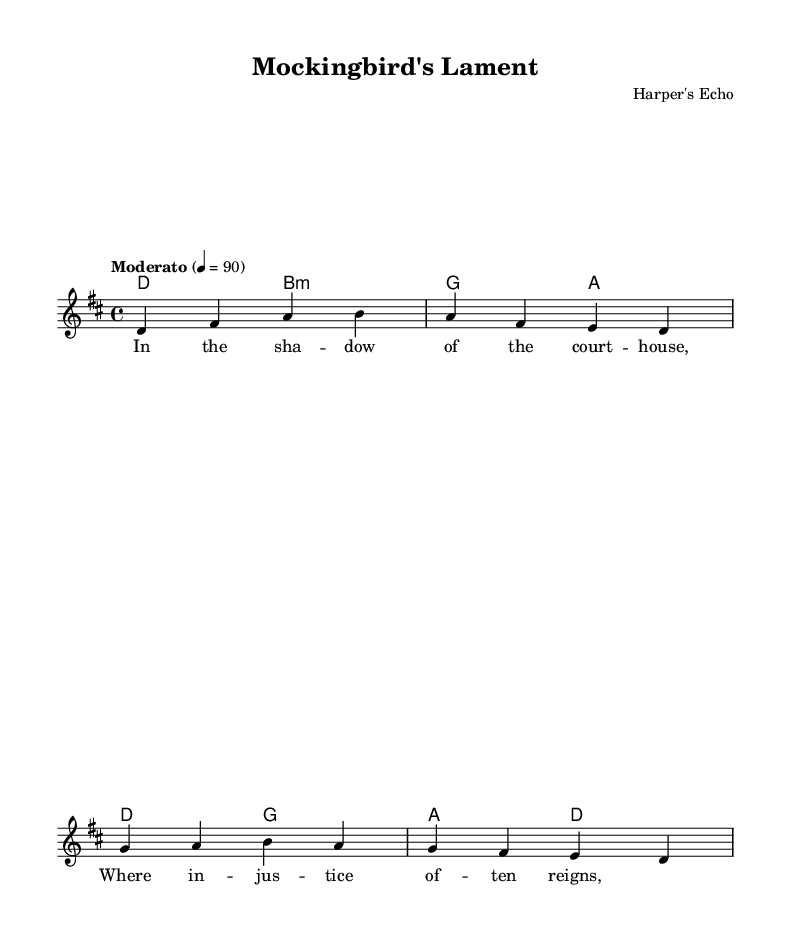What is the key signature of this music? The key signature is indicated by the presence of two sharps, which correspond to F# and C#. This confirms that the piece is in D major.
Answer: D major What is the time signature of this music? The time signature is located at the beginning of the score, showing '4/4', which indicates that there are four beats in each measure and a quarter note receives one beat.
Answer: 4/4 What is the tempo marking of this piece? The tempo marking is given in the score as "Moderato," which denotes a moderate pace. The corresponding beats per minute are indicated as 90, signaling how fast the piece should be played.
Answer: Moderato How many measures are there in the melody? By counting the distinct sections divided by vertical bar lines in the melody line, we find that it consists of four measures.
Answer: 4 What is the name of this piece? The title of the piece is featured prominently at the top of the score as "Mockingbird's Lament," directly indicating its name.
Answer: Mockingbird's Lament Who is the composer of this piece? The composer’s information is provided under the title of the piece; thus, it identifies "Harper's Echo" as the individual or group behind the composition.
Answer: Harper's Echo What thematic message is suggested by the lyrics? The lyrics presented discuss themes of justice and social issues as indicated by the line referencing the courthouse and the nature of justice, which suggests a focus on societal challenges.
Answer: Social justice 